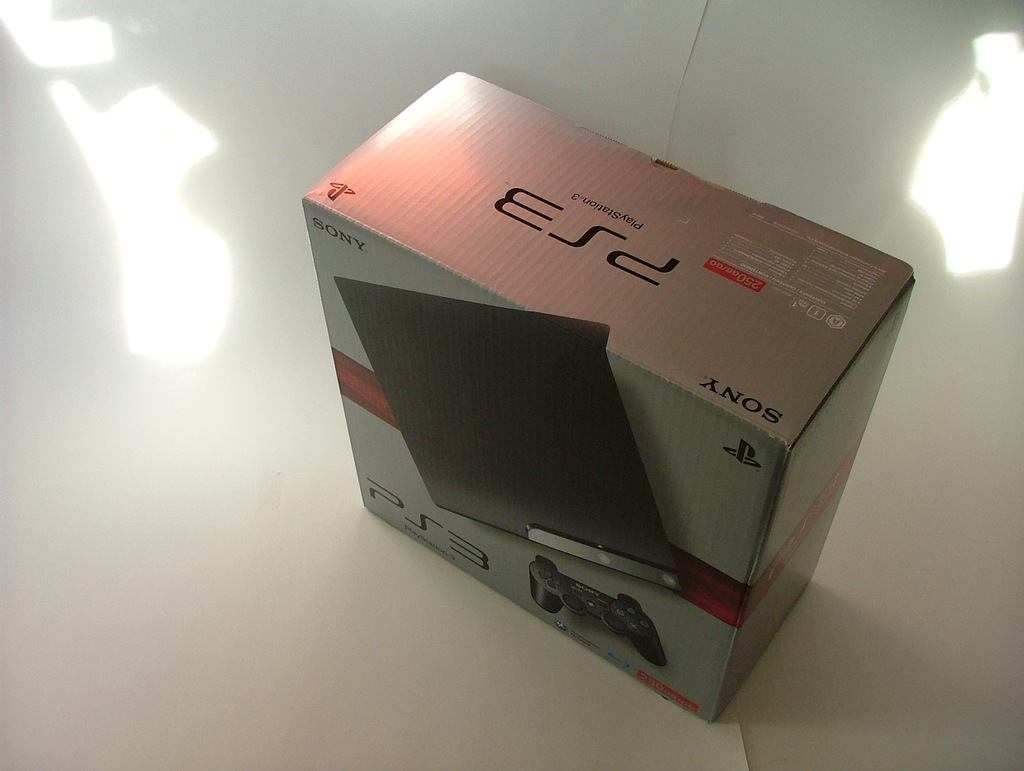Provide a one-sentence caption for the provided image. A brand new Sony PlayStation 3 console, still sealed in its original packaging, is displayed on a reflective white surface, illuminated by overhead lighting that casts soft reflections and shadows. 